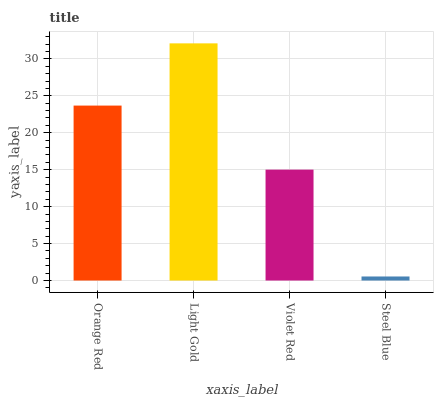Is Steel Blue the minimum?
Answer yes or no. Yes. Is Light Gold the maximum?
Answer yes or no. Yes. Is Violet Red the minimum?
Answer yes or no. No. Is Violet Red the maximum?
Answer yes or no. No. Is Light Gold greater than Violet Red?
Answer yes or no. Yes. Is Violet Red less than Light Gold?
Answer yes or no. Yes. Is Violet Red greater than Light Gold?
Answer yes or no. No. Is Light Gold less than Violet Red?
Answer yes or no. No. Is Orange Red the high median?
Answer yes or no. Yes. Is Violet Red the low median?
Answer yes or no. Yes. Is Light Gold the high median?
Answer yes or no. No. Is Light Gold the low median?
Answer yes or no. No. 